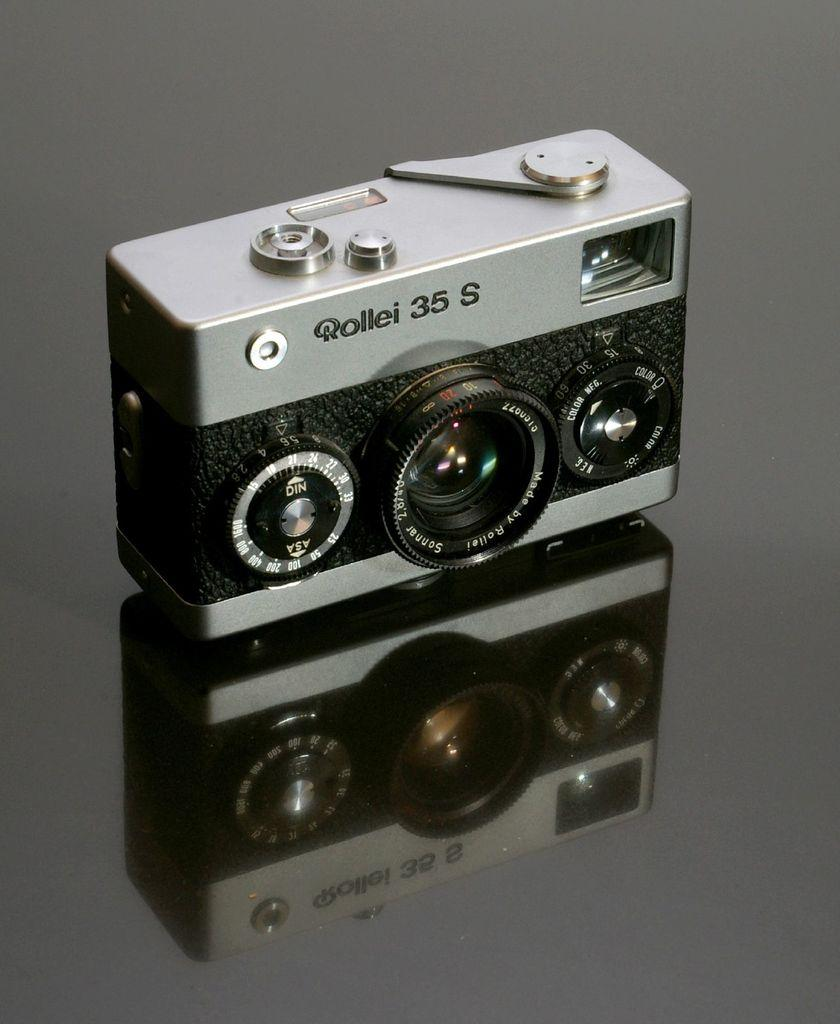What is the main object in the picture? There is a camera in the picture. Where is the camera placed? The camera is placed on a glass table. Can you describe any additional details about the camera's appearance in the picture? The reflection of the camera is visible at the bottom of the picture. What type of invention is the ant using to communicate with the men in the picture? There are no ants or men present in the picture, and therefore no such interaction can be observed. 